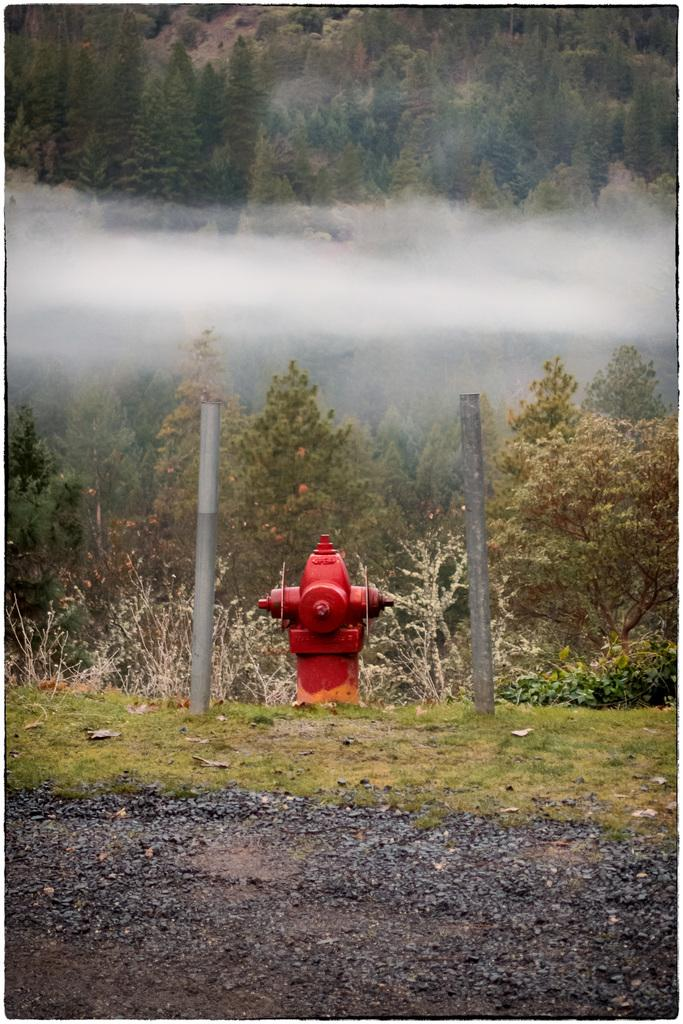What type of surface can be seen in the image? The ground is visible in the image. What type of vegetation is present in the image? There is grass, plants, and trees in the image. What man-made structures can be seen in the image? There are poles in the image. What is the color of the object in the image? There is a red colored object in the image. What is the natural phenomenon visible in the image? There is smoke visible in the image. What word is being spelled out by the string of lights in the image? There are no lights or words present in the image. 